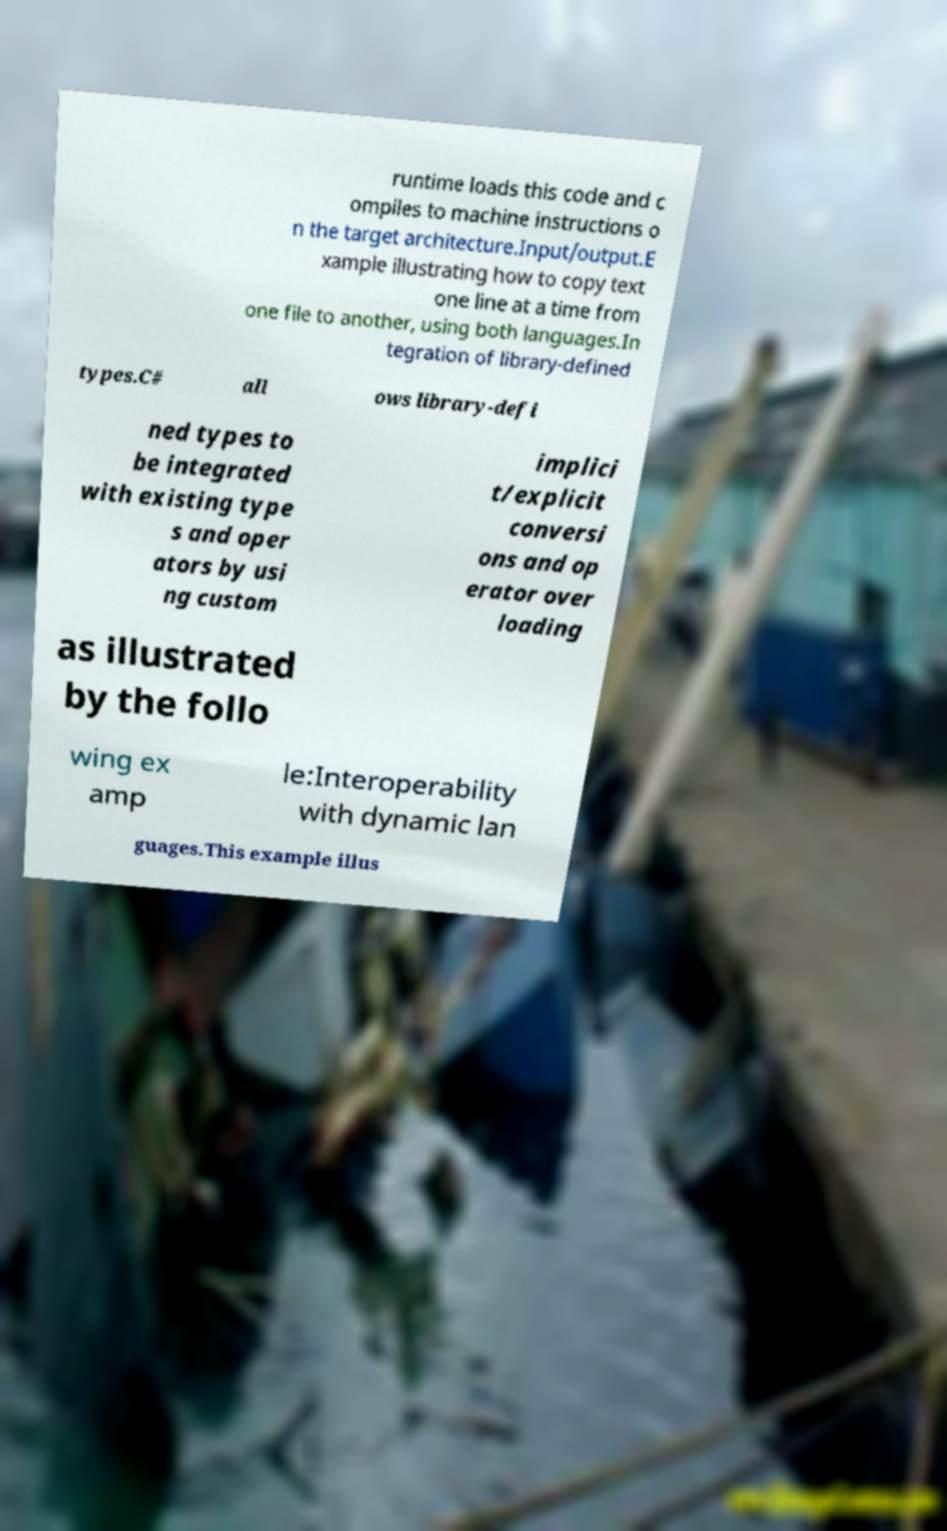What messages or text are displayed in this image? I need them in a readable, typed format. runtime loads this code and c ompiles to machine instructions o n the target architecture.Input/output.E xample illustrating how to copy text one line at a time from one file to another, using both languages.In tegration of library-defined types.C# all ows library-defi ned types to be integrated with existing type s and oper ators by usi ng custom implici t/explicit conversi ons and op erator over loading as illustrated by the follo wing ex amp le:Interoperability with dynamic lan guages.This example illus 